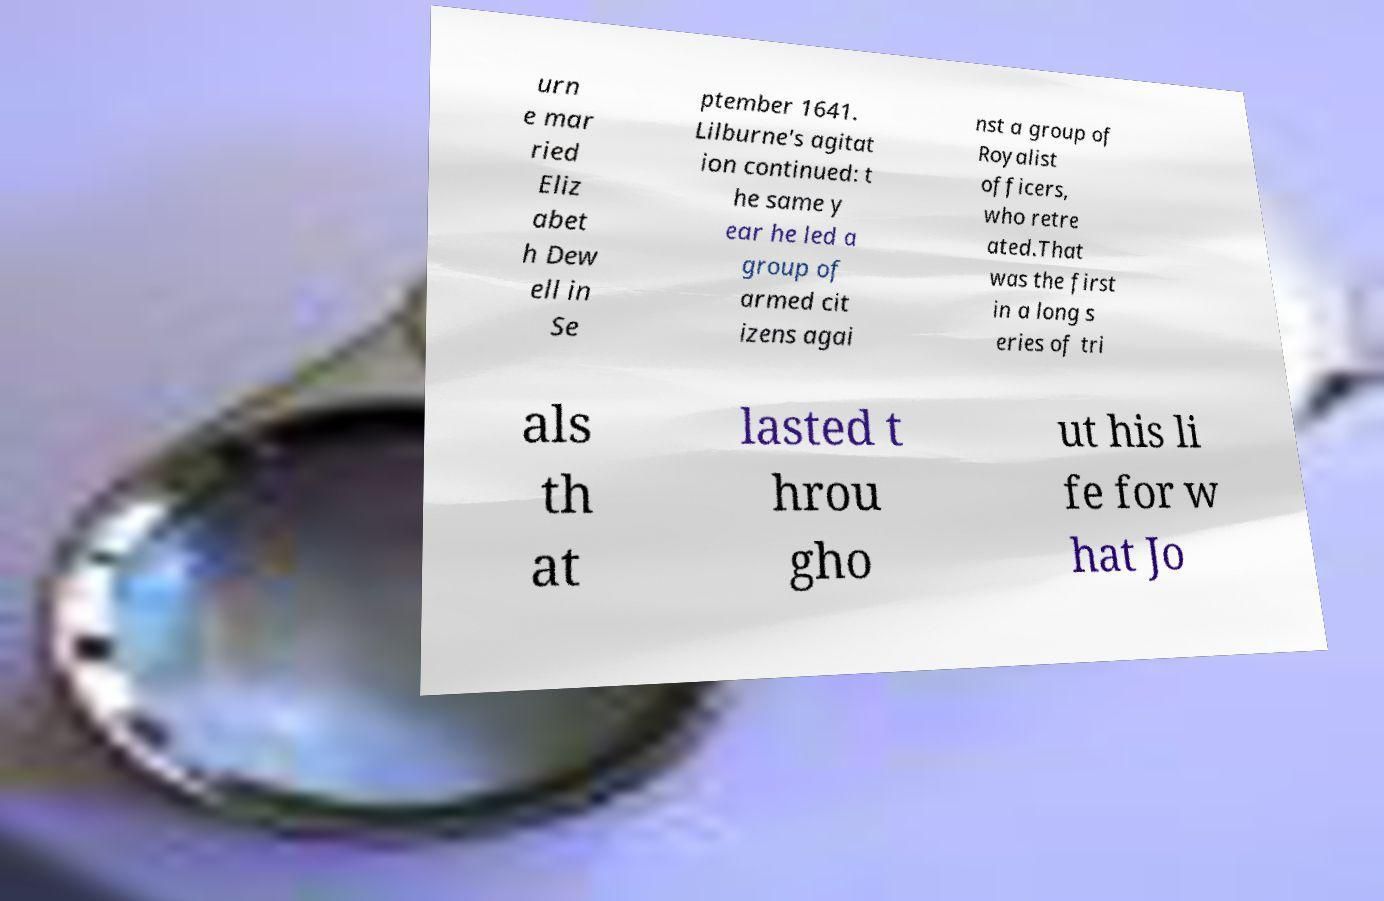I need the written content from this picture converted into text. Can you do that? urn e mar ried Eliz abet h Dew ell in Se ptember 1641. Lilburne's agitat ion continued: t he same y ear he led a group of armed cit izens agai nst a group of Royalist officers, who retre ated.That was the first in a long s eries of tri als th at lasted t hrou gho ut his li fe for w hat Jo 